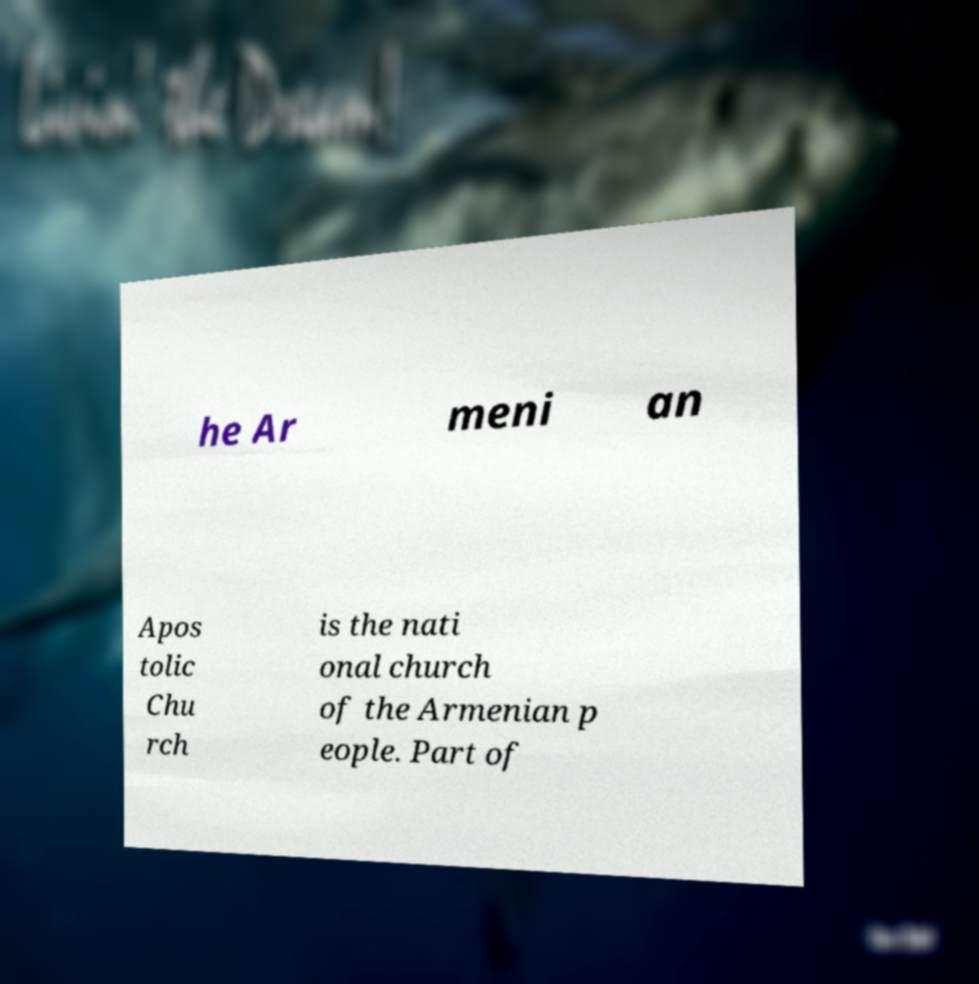What messages or text are displayed in this image? I need them in a readable, typed format. he Ar meni an Apos tolic Chu rch is the nati onal church of the Armenian p eople. Part of 